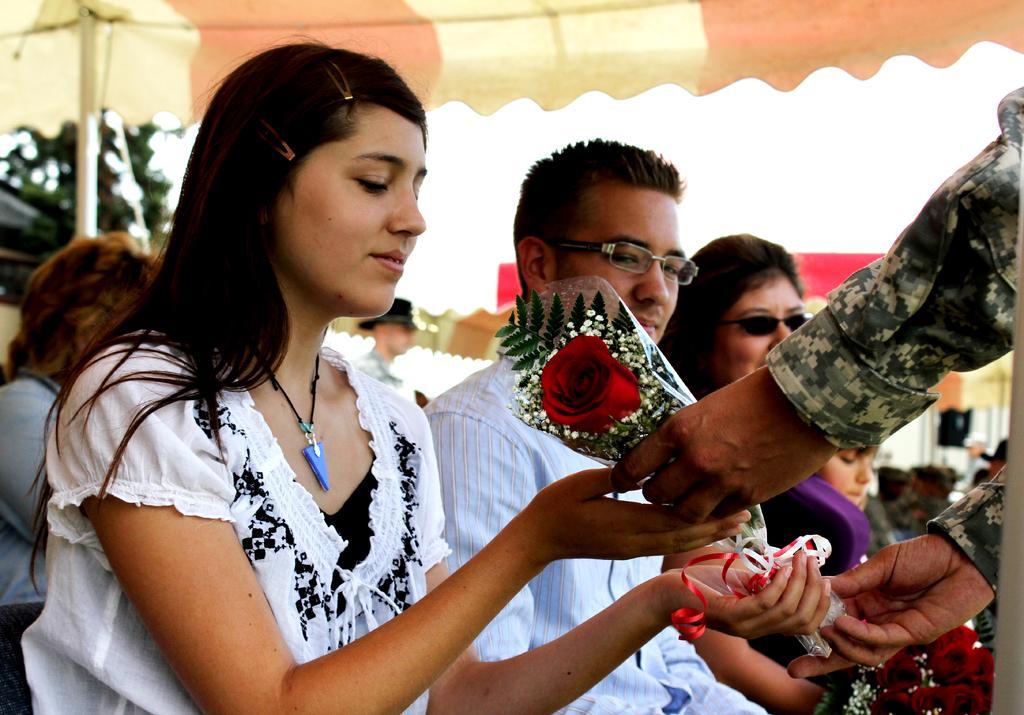Please provide a concise description of this image. In this image I can see group of people sitting. In front the person is wearing white and black color dress and I can see the flower in red color. Background I can see few other people, few tents, trees in green color and the sky is in white color. 